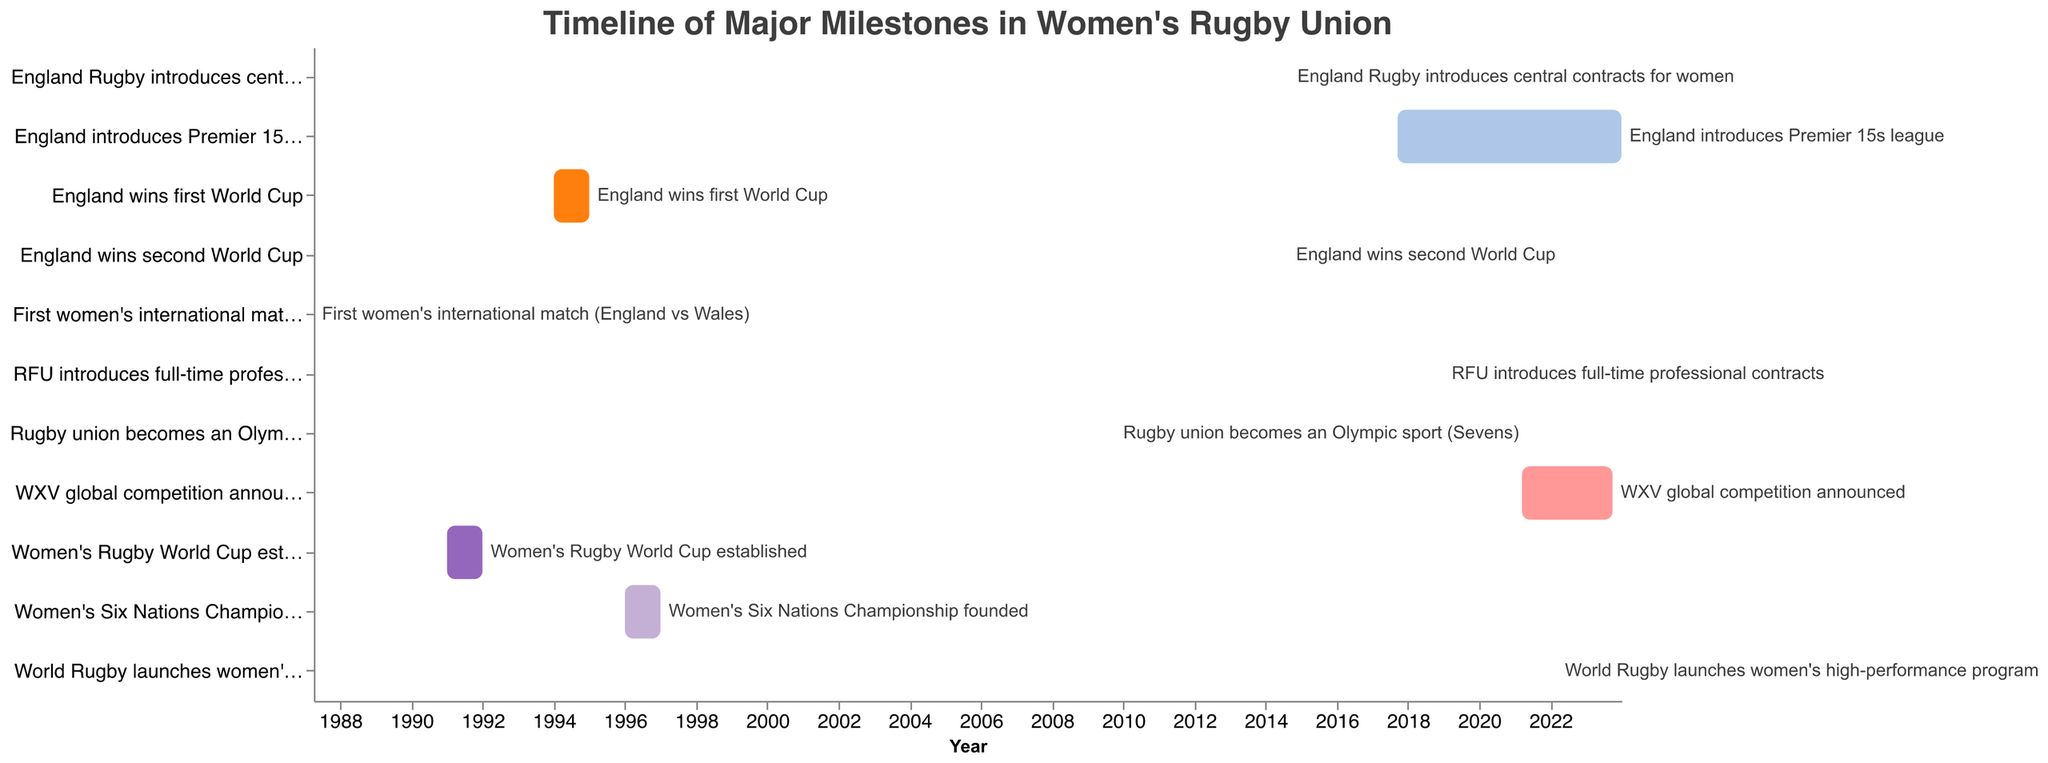What is the date of the first women's international rugby match according to the chart? The bar corresponding to "First women's international match (England vs Wales)" starts and ends on April 5, 1987.
Answer: April 5, 1987 When was the Women's Rugby World Cup established? The bar for "Women's Rugby World Cup established" spans from January 1, 1991, to December 31, 1991.
Answer: 1991 How many years after the first England women's international match was the Women's Six Nations Championship founded? The first women's international match is in 1987, and the Women's Six Nations Championship was established in 1996. The difference is 1996 - 1987 = 9 years.
Answer: 9 years Which milestone took place the most recently according to the chart? The latest end date is for "England introduces Premier 15s league," ending on December 31, 2023.
Answer: England introduces Premier 15s league Between "England Rugby introduces central contracts for women" and "RFU introduces full-time professional contracts," which event occurred earlier? According to the Gantt chart, "England Rugby introduces central contracts for women" occurred on September 1, 2014, while "RFU introduces full-time professional contracts" took place on January 1, 2019.
Answer: England Rugby introduces central contracts for women How long did it take for England to win their second World Cup after the tournament's introduction? The Women's Rugby World Cup was established in 1991, and England won their second World Cup in 2014. The time difference is 2014 - 1991 = 23 years.
Answer: 23 years On which date did rugby union become an Olympic sport (Sevens)? The event "Rugby union becomes an Olympic sport (Sevens)" is marked on October 9, 2009.
Answer: October 9, 2009 Is the "WXV global competition" timeline still ongoing? The end date for "WXV global competition announced" is October 1, 2023. Since this is in the future, it suggests the timeline is ongoing.
Answer: Yes What is the longest ongoing milestone mentioned in the chart? The milestone "England introduces Premier 15s league" spans from September 16, 2017, to December 31, 2023. This is the longest ongoing timeline in the chart.
Answer: England introduces Premier 15s league 